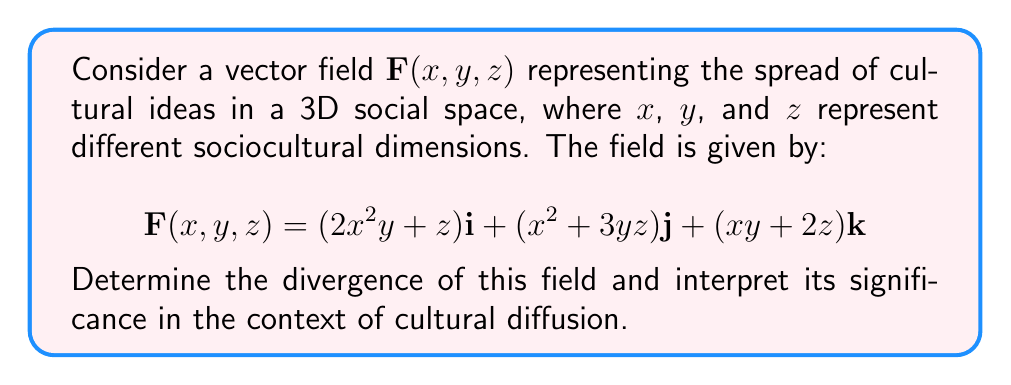What is the answer to this math problem? To solve this problem, we'll follow these steps:

1) The divergence of a vector field $\mathbf{F}(x,y,z) = P\mathbf{i} + Q\mathbf{j} + R\mathbf{k}$ is given by:

   $$\text{div}\mathbf{F} = \nabla \cdot \mathbf{F} = \frac{\partial P}{\partial x} + \frac{\partial Q}{\partial y} + \frac{\partial R}{\partial z}$$

2) In our case:
   $P = 2x^2y + z$
   $Q = x^2 + 3yz$
   $R = xy + 2z$

3) Let's calculate each partial derivative:

   $\frac{\partial P}{\partial x} = 4xy$
   
   $\frac{\partial Q}{\partial y} = 3z$
   
   $\frac{\partial R}{\partial z} = 2$

4) Now, we sum these partial derivatives:

   $$\text{div}\mathbf{F} = 4xy + 3z + 2$$

5) Interpretation: The divergence represents the rate at which cultural ideas are spreading (or converging) at any point in the sociocultural space. A positive divergence indicates that ideas are spreading outward or becoming more diverse, while a negative divergence would suggest ideas are converging or becoming more uniform.

   In this case, the divergence is always positive (since $4xy + 3z + 2 > 0$ for all real $x$, $y$, and $z$), indicating that cultural ideas are consistently spreading and diversifying throughout the sociocultural space. The rate of spread increases with larger values of $x$, $y$, and $z$, suggesting that diversity begets further diversity in this model.
Answer: $4xy + 3z + 2$ 